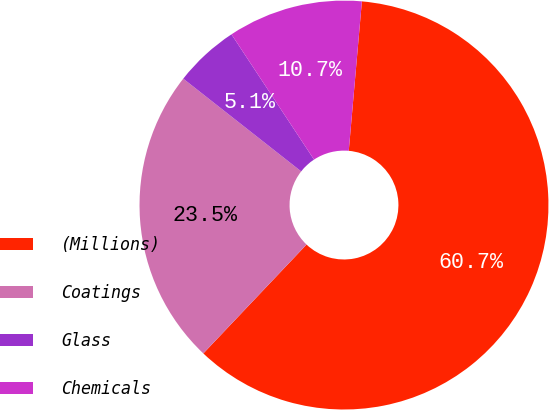Convert chart. <chart><loc_0><loc_0><loc_500><loc_500><pie_chart><fcel>(Millions)<fcel>Coatings<fcel>Glass<fcel>Chemicals<nl><fcel>60.68%<fcel>23.53%<fcel>5.12%<fcel>10.67%<nl></chart> 